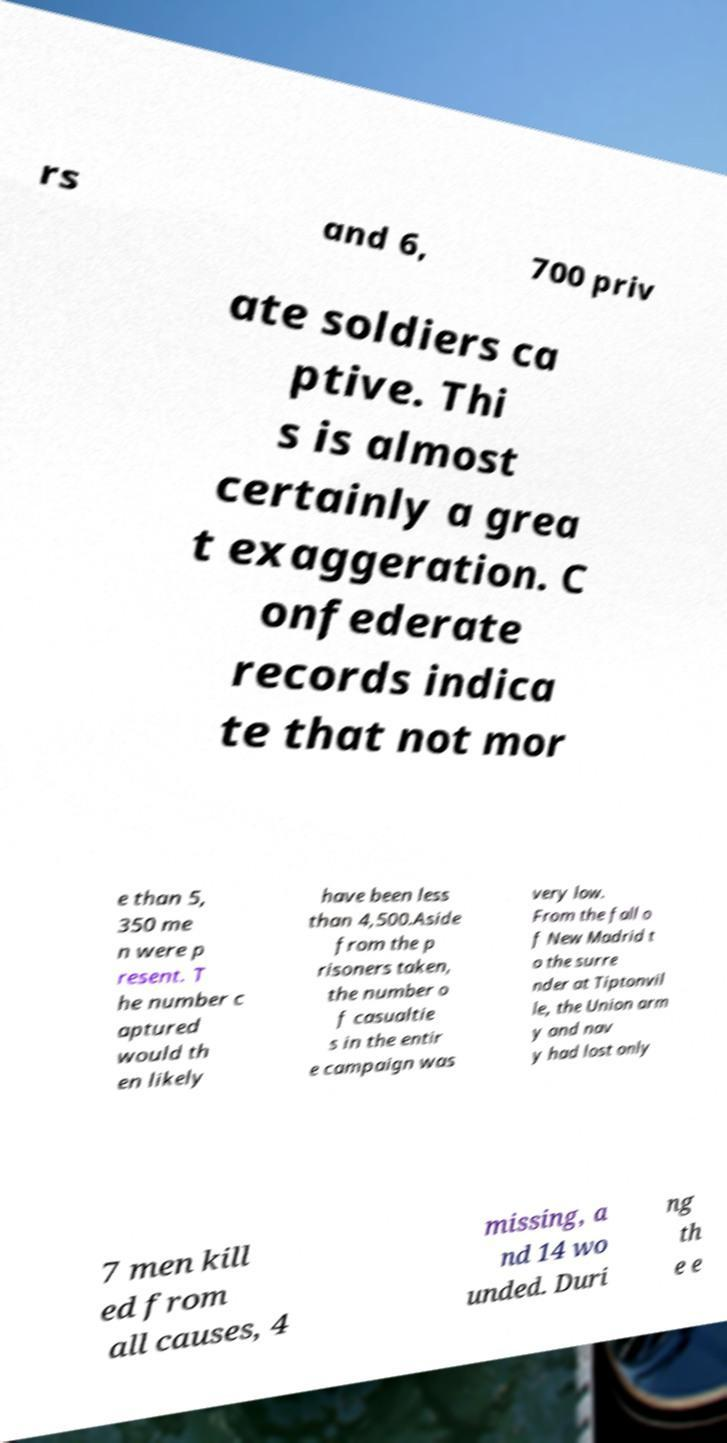Can you accurately transcribe the text from the provided image for me? rs and 6, 700 priv ate soldiers ca ptive. Thi s is almost certainly a grea t exaggeration. C onfederate records indica te that not mor e than 5, 350 me n were p resent. T he number c aptured would th en likely have been less than 4,500.Aside from the p risoners taken, the number o f casualtie s in the entir e campaign was very low. From the fall o f New Madrid t o the surre nder at Tiptonvil le, the Union arm y and nav y had lost only 7 men kill ed from all causes, 4 missing, a nd 14 wo unded. Duri ng th e e 